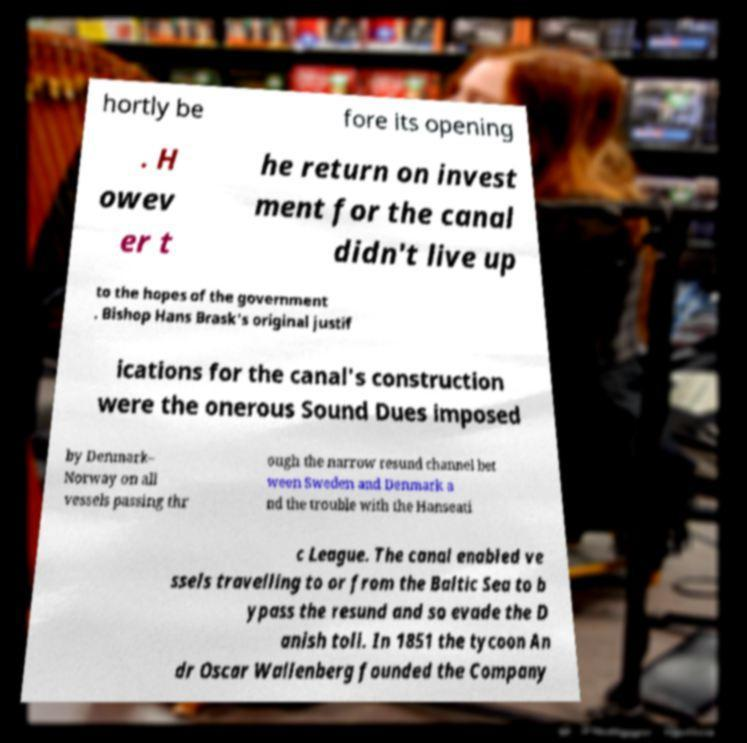Please read and relay the text visible in this image. What does it say? hortly be fore its opening . H owev er t he return on invest ment for the canal didn't live up to the hopes of the government . Bishop Hans Brask's original justif ications for the canal's construction were the onerous Sound Dues imposed by Denmark– Norway on all vessels passing thr ough the narrow resund channel bet ween Sweden and Denmark a nd the trouble with the Hanseati c League. The canal enabled ve ssels travelling to or from the Baltic Sea to b ypass the resund and so evade the D anish toll. In 1851 the tycoon An dr Oscar Wallenberg founded the Company 